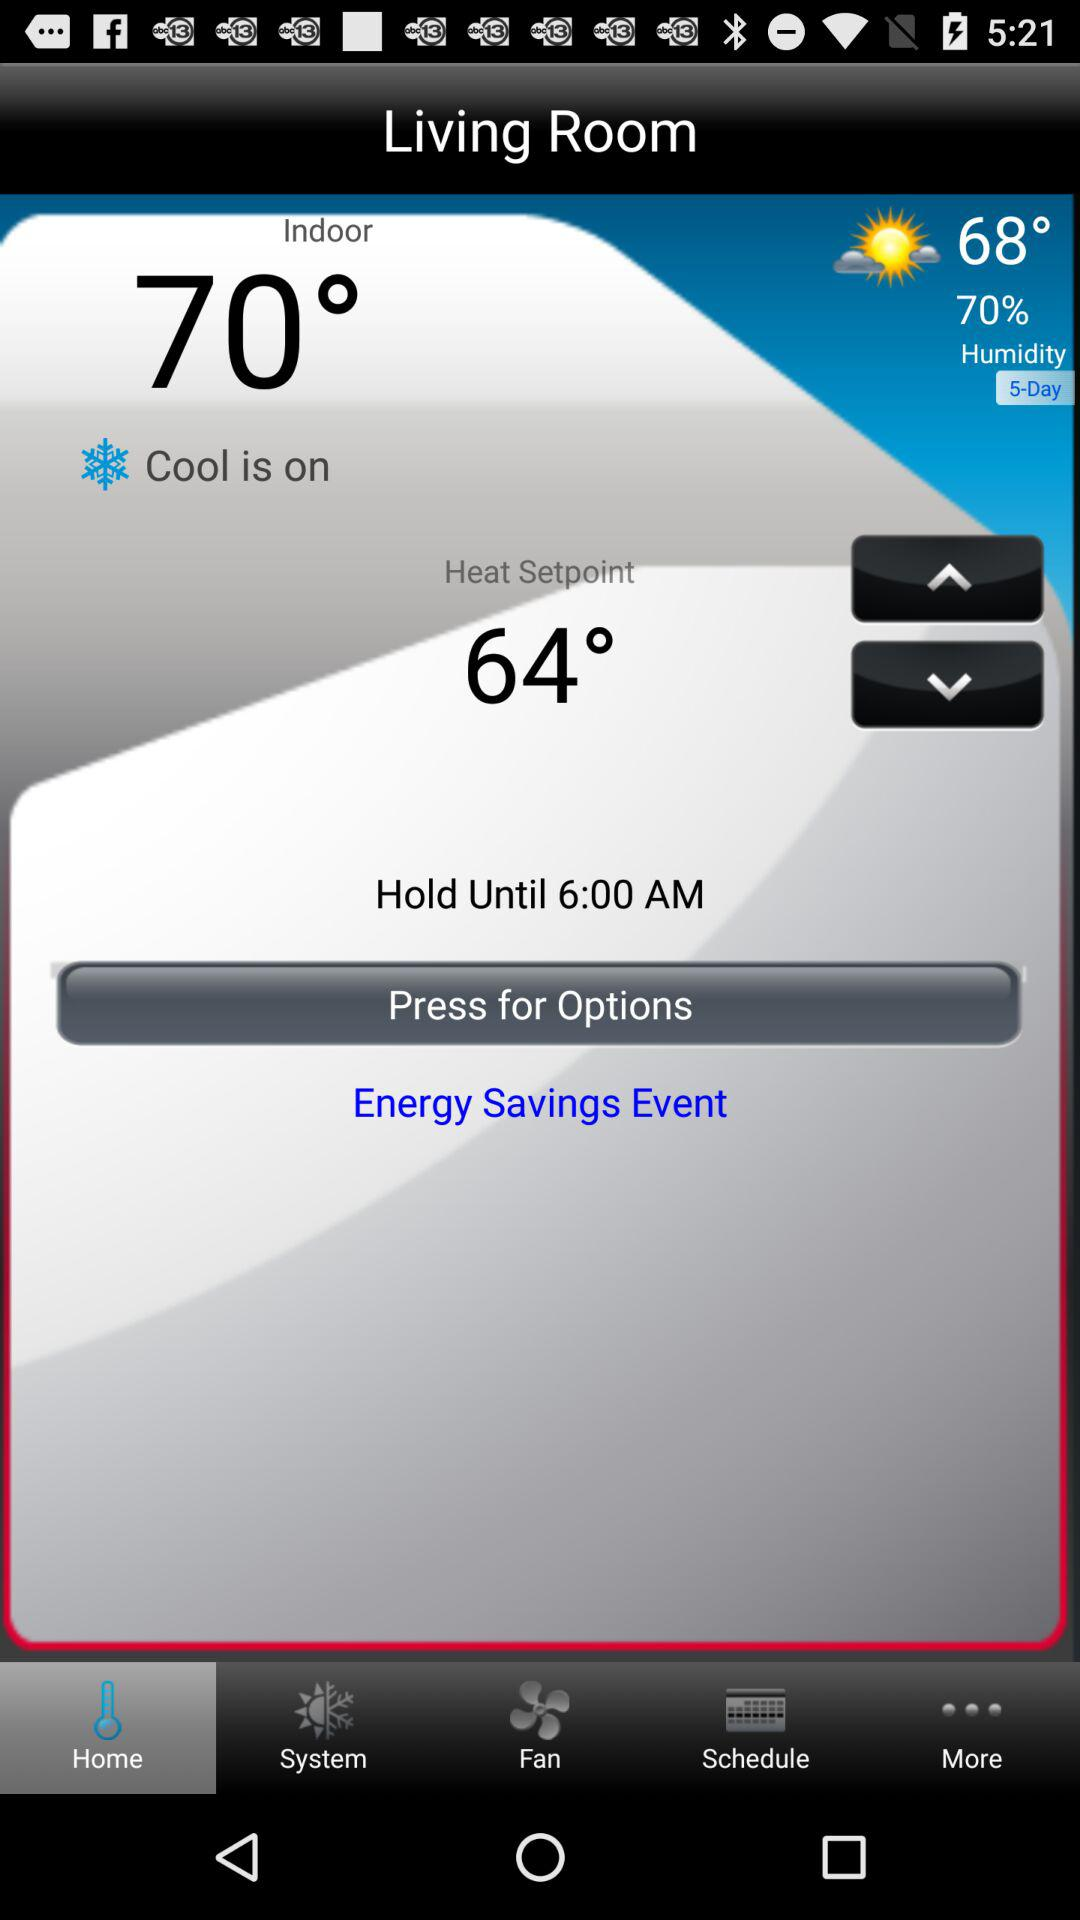What is the heat setpoint temperature? The heat setpoint temperature is 64 degrees. 